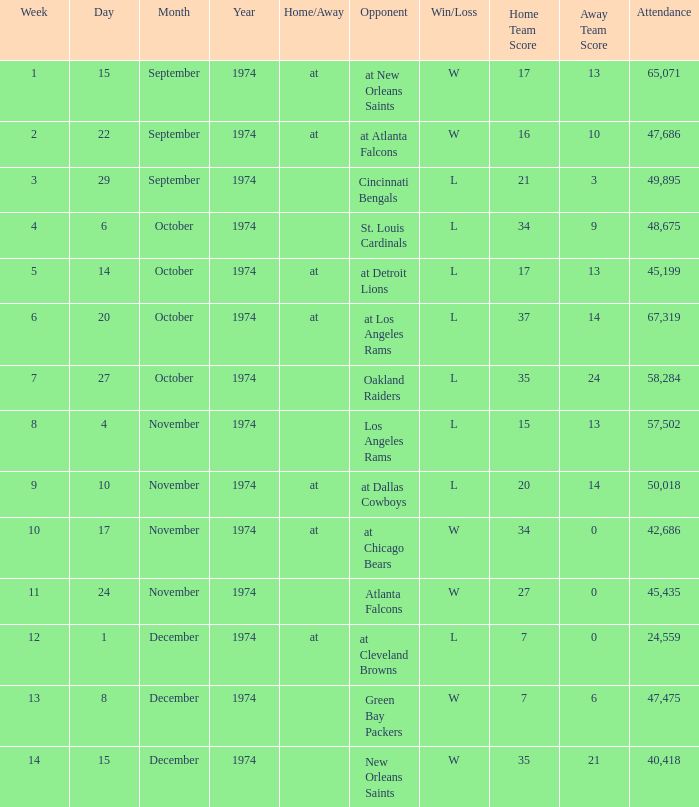Which week was the game played on December 8, 1974? 13.0. 